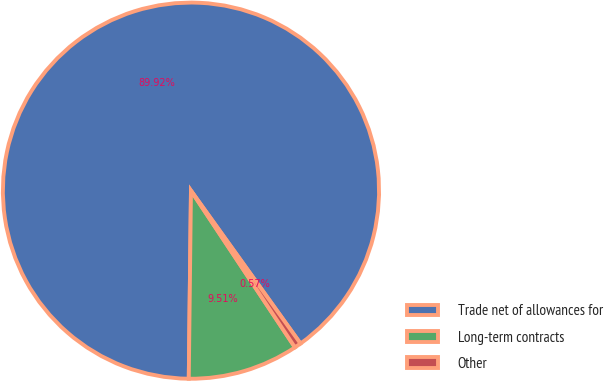<chart> <loc_0><loc_0><loc_500><loc_500><pie_chart><fcel>Trade net of allowances for<fcel>Long-term contracts<fcel>Other<nl><fcel>89.92%<fcel>9.51%<fcel>0.57%<nl></chart> 